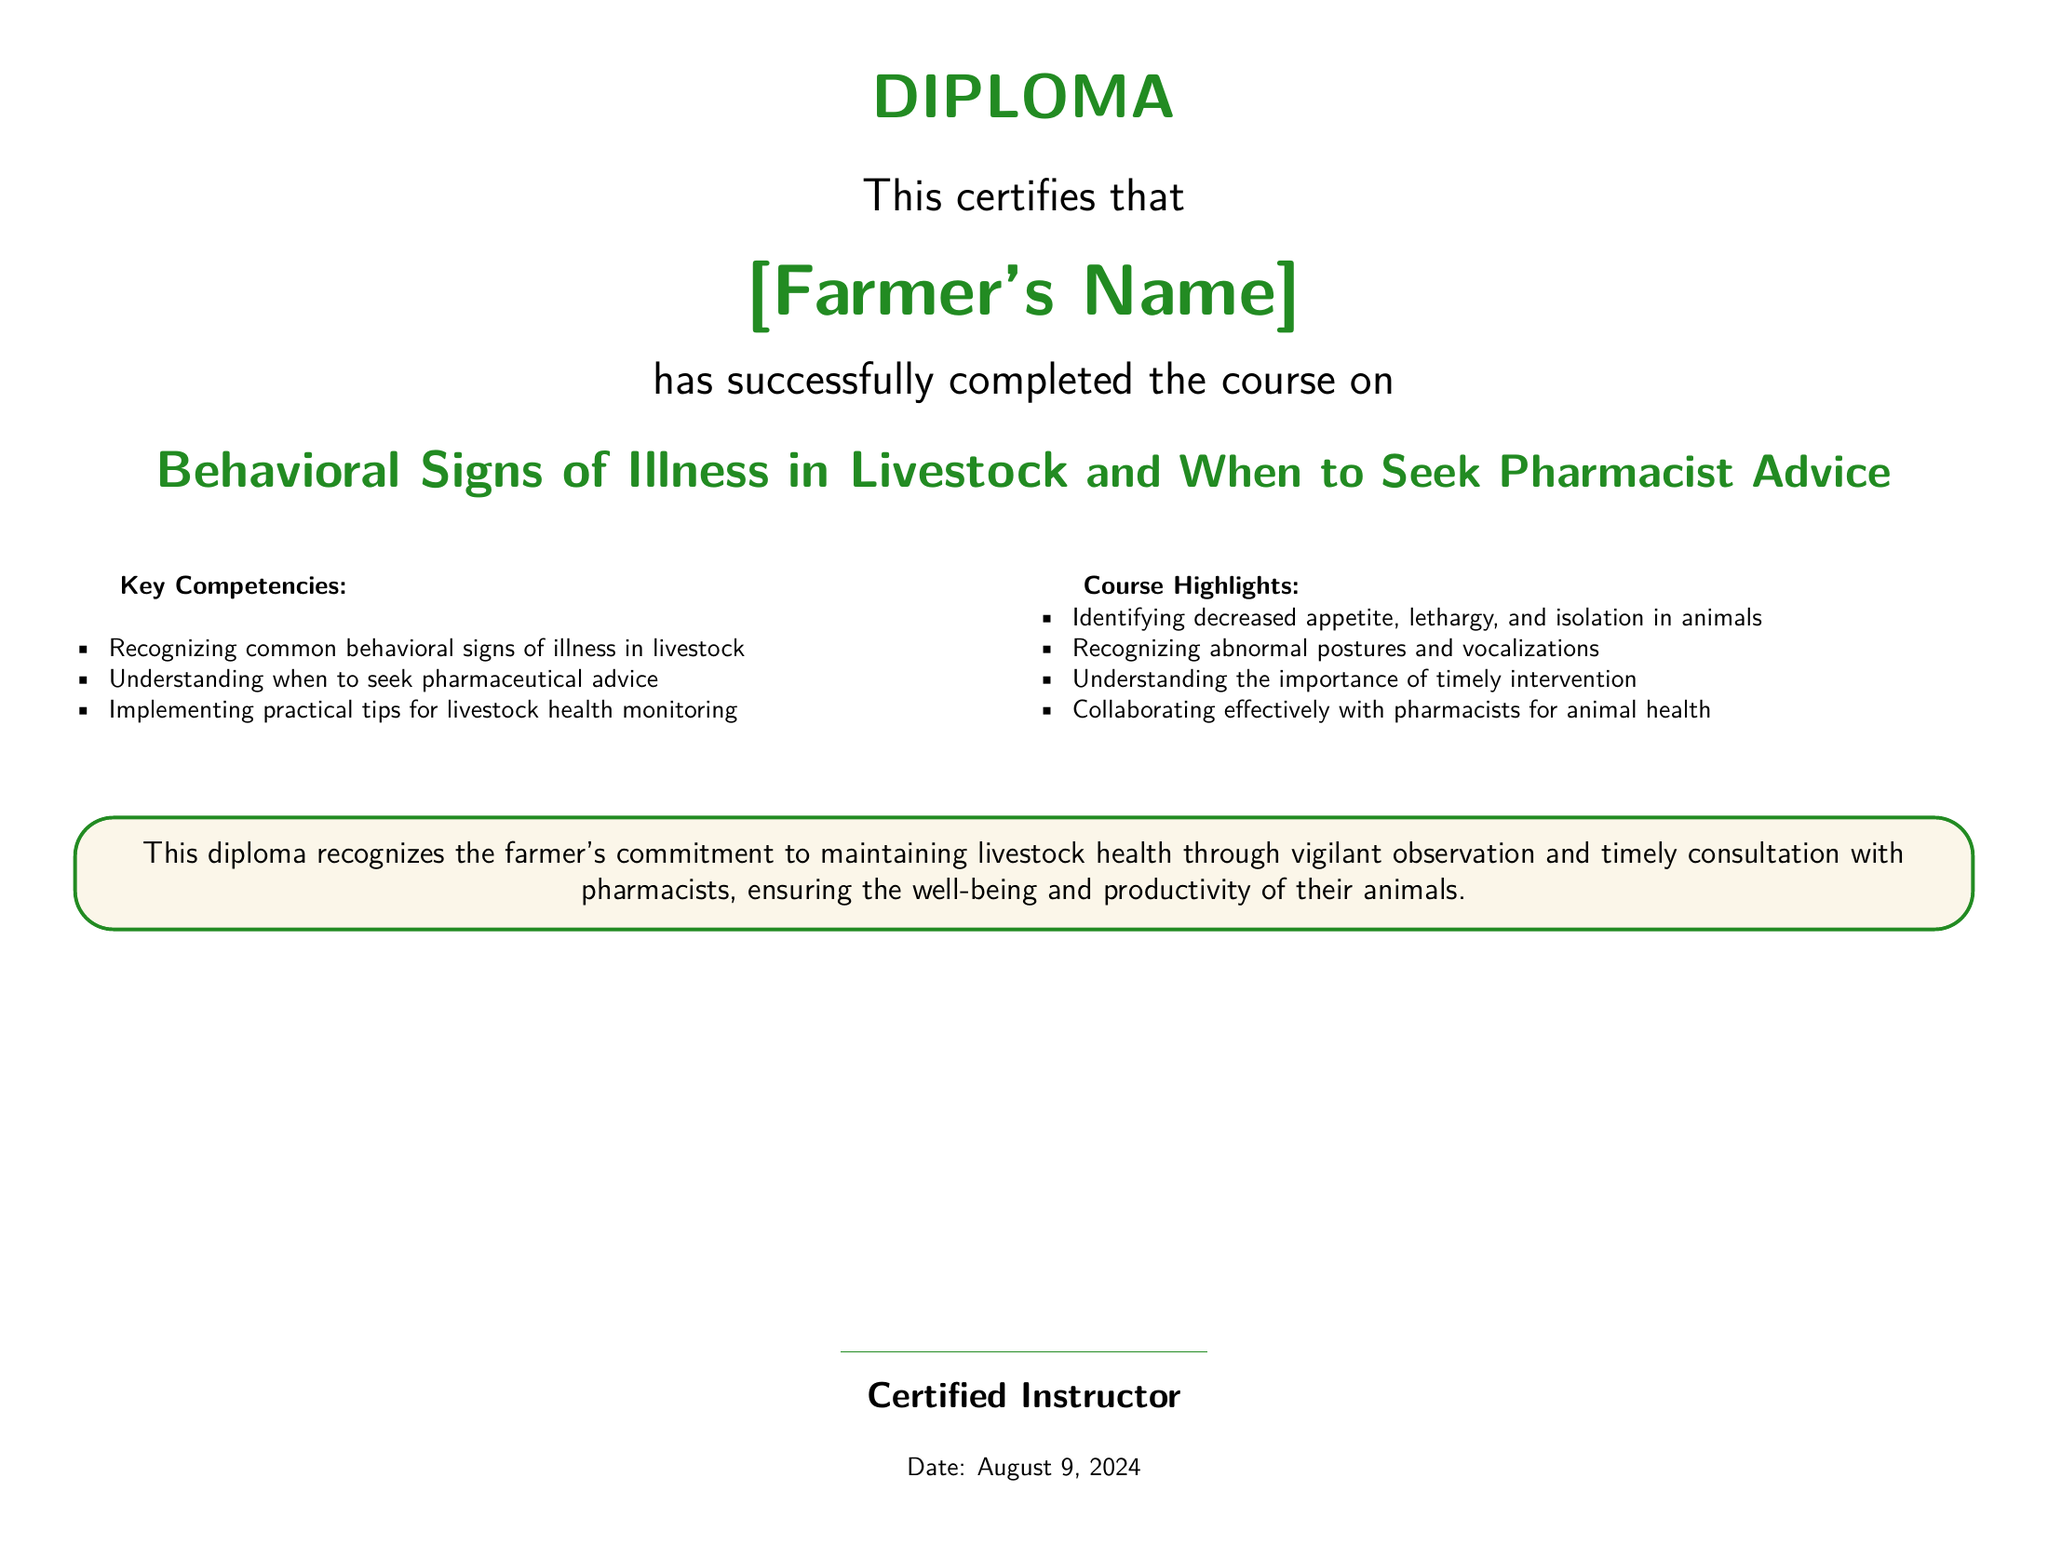What is the title of the course? The title of the course is stated prominently in the document as "Behavioral Signs of Illness in Livestock and When to Seek Pharmacist Advice".
Answer: Behavioral Signs of Illness in Livestock and When to Seek Pharmacist Advice Who completed the course? The diploma is issued to a specific individual, which is highlighted in the document as [Farmer's Name].
Answer: [Farmer's Name] What color is used for the text in the title? The title text uses the color defined as farmgreen, which can be identified in the color specifications.
Answer: farmgreen How many key competencies are listed? The document itemizes the key competencies, and there are three competencies mentioned.
Answer: 3 What is one behavioral sign of illness in livestock mentioned? The document lists several signs, and one example provided is "decreased appetite".
Answer: decreased appetite In what manner should farmers consult with pharmacists according to the course? The document emphasizes the importance of "collaborating effectively" with pharmacists for animal health.
Answer: collaborating effectively What is the significance of the diploma according to the text? The diploma recognizes the farmer's commitment to maintaining livestock health through observation and consultation, as stated in the tcolorbox.
Answer: commitment to maintaining livestock health What date is mentioned in the document? The document includes a placeholder for the date, which is provided as "today".
Answer: today 